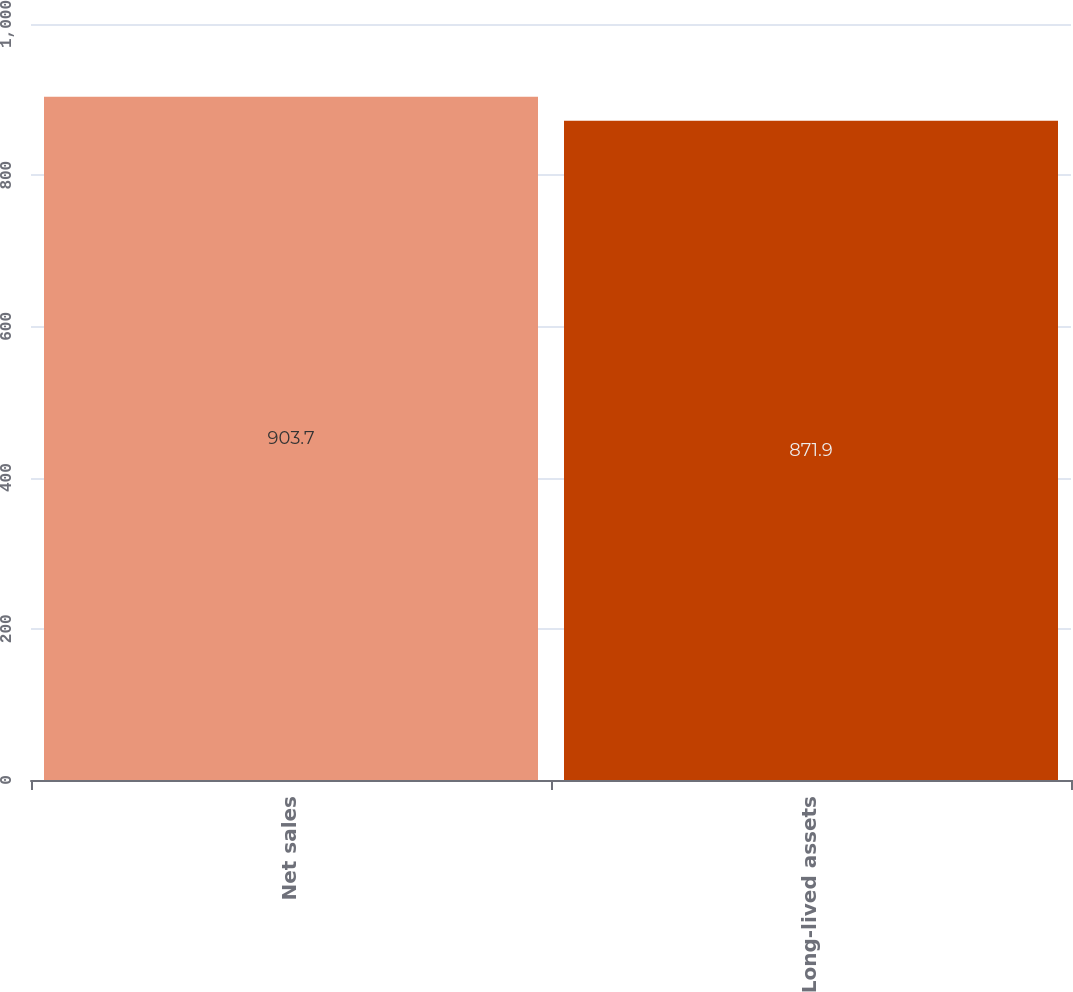<chart> <loc_0><loc_0><loc_500><loc_500><bar_chart><fcel>Net sales<fcel>Long-lived assets<nl><fcel>903.7<fcel>871.9<nl></chart> 